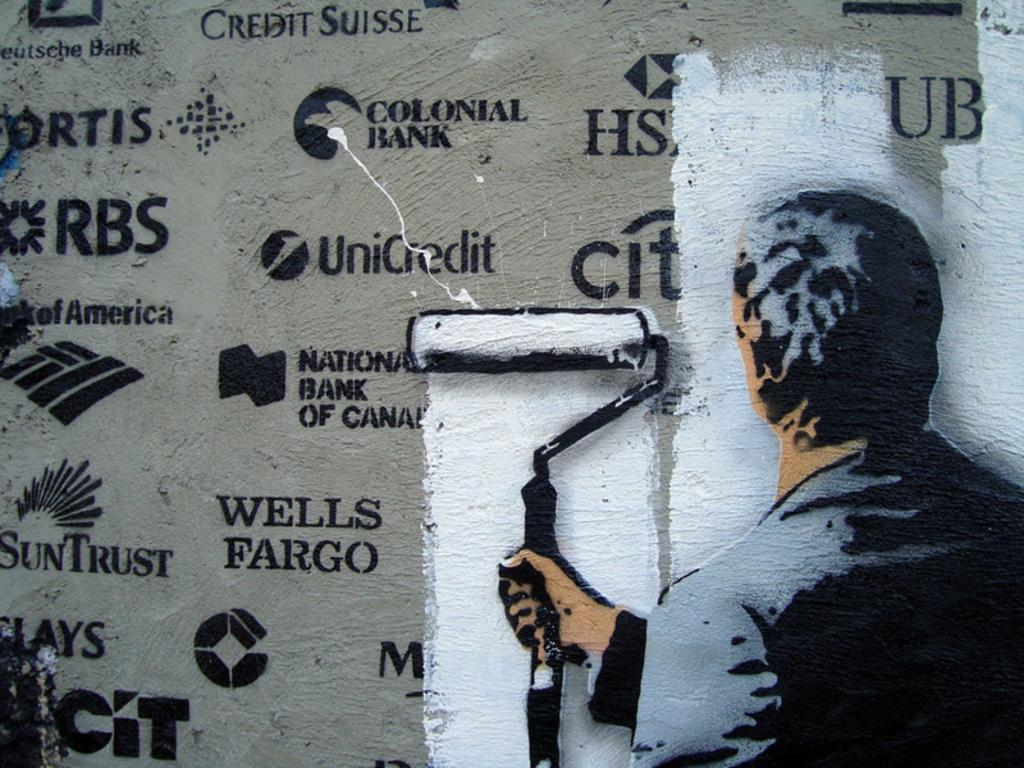<image>
Summarize the visual content of the image. A man using a paint roller to paint white paint over Wells Fargo and other bank names. 